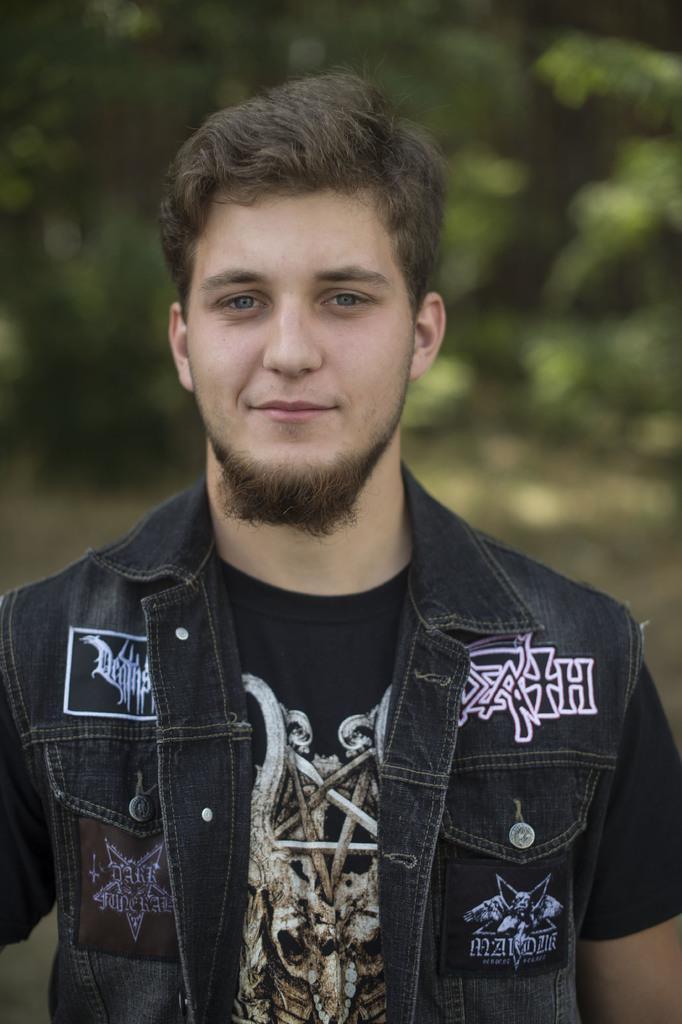Please provide a concise description of this image. In this image we can see a person in the foreground and he is looking at someone and having black hair and the background is blurred. 